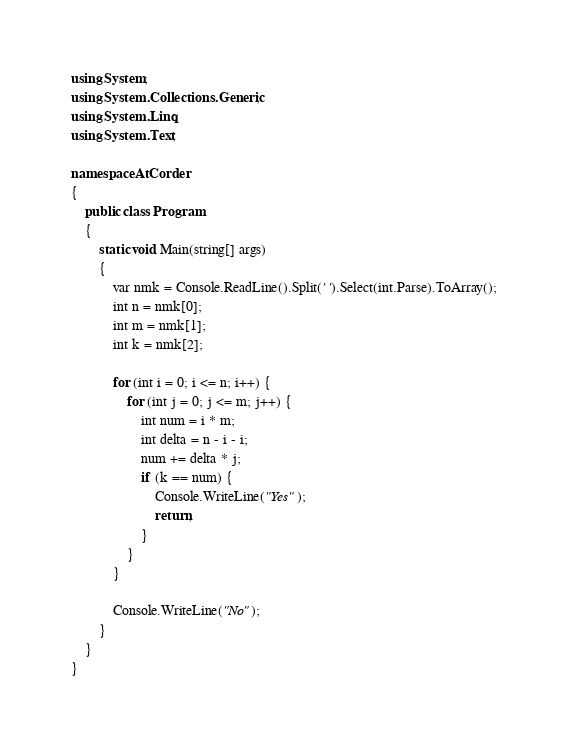Convert code to text. <code><loc_0><loc_0><loc_500><loc_500><_C#_>using System;
using System.Collections.Generic;
using System.Linq;
using System.Text;

namespace AtCorder
{
	public class Program
	{
		static void Main(string[] args)
		{
			var nmk = Console.ReadLine().Split(' ').Select(int.Parse).ToArray();
			int n = nmk[0];
			int m = nmk[1];
			int k = nmk[2];

			for (int i = 0; i <= n; i++) {
				for (int j = 0; j <= m; j++) {
					int num = i * m;
					int delta = n - i - i;
					num += delta * j;
					if (k == num) {
						Console.WriteLine("Yes");
						return;
					}
				}
			}

			Console.WriteLine("No");
		}
	}
}
</code> 